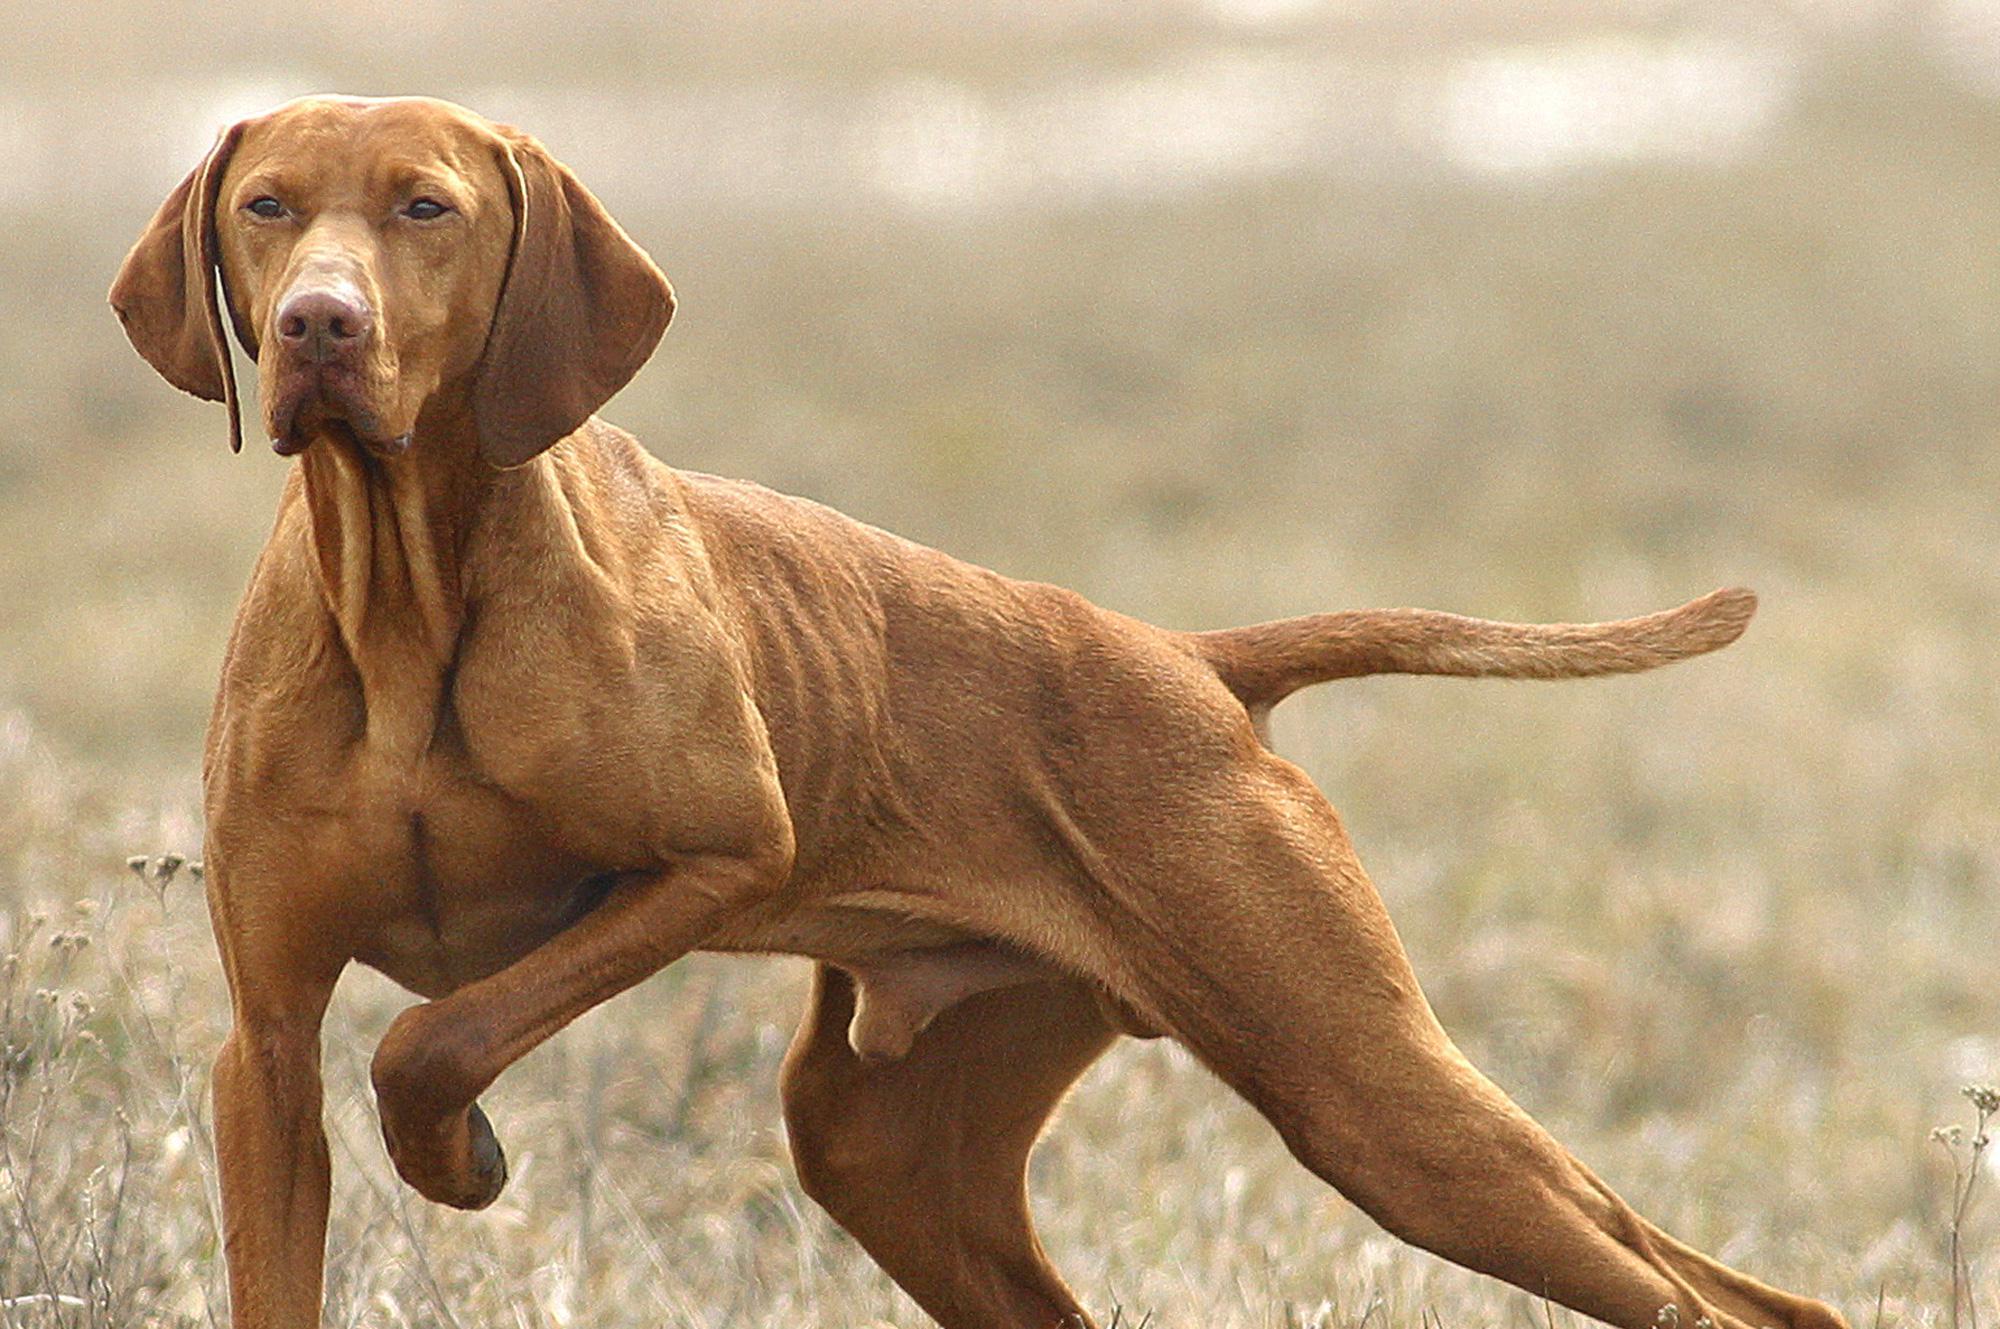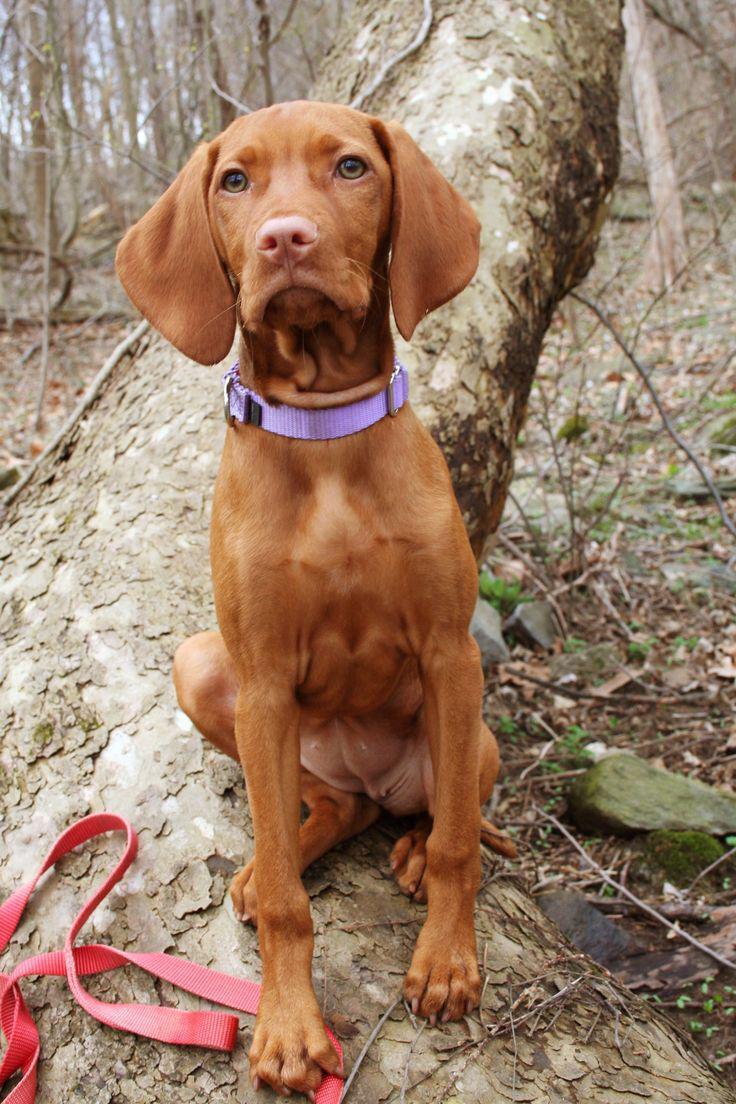The first image is the image on the left, the second image is the image on the right. Evaluate the accuracy of this statement regarding the images: "A dog has at least one front paw off the ground.". Is it true? Answer yes or no. Yes. The first image is the image on the left, the second image is the image on the right. Assess this claim about the two images: "The dog on the right is posed with a hunting weapon and a fowl, while the dog on the left has a very visible collar.". Correct or not? Answer yes or no. No. 